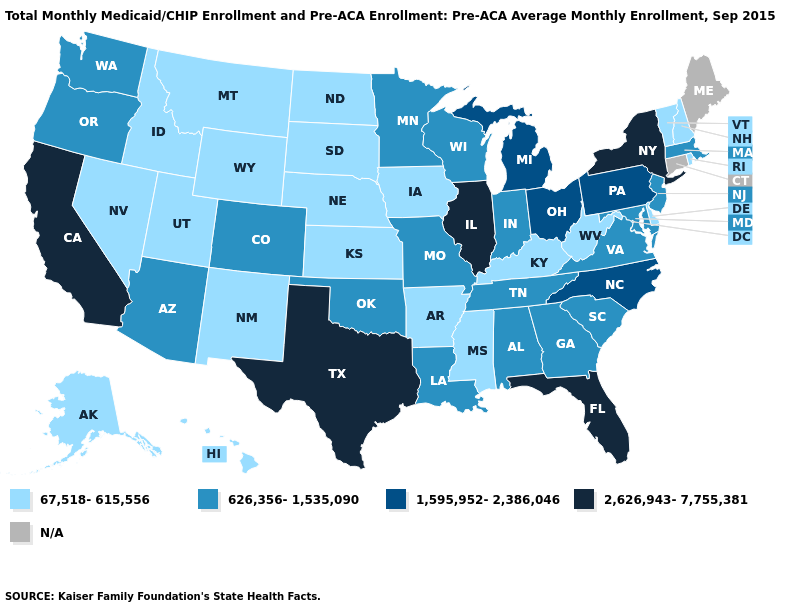Which states have the lowest value in the USA?
Be succinct. Alaska, Arkansas, Delaware, Hawaii, Idaho, Iowa, Kansas, Kentucky, Mississippi, Montana, Nebraska, Nevada, New Hampshire, New Mexico, North Dakota, Rhode Island, South Dakota, Utah, Vermont, West Virginia, Wyoming. What is the lowest value in the Northeast?
Short answer required. 67,518-615,556. Name the states that have a value in the range 2,626,943-7,755,381?
Quick response, please. California, Florida, Illinois, New York, Texas. Does California have the highest value in the USA?
Short answer required. Yes. Among the states that border Arkansas , does Louisiana have the highest value?
Quick response, please. No. Among the states that border Michigan , does Indiana have the lowest value?
Answer briefly. Yes. What is the lowest value in the USA?
Quick response, please. 67,518-615,556. Does Missouri have the lowest value in the USA?
Write a very short answer. No. Does the map have missing data?
Be succinct. Yes. Among the states that border Indiana , which have the lowest value?
Quick response, please. Kentucky. What is the value of Georgia?
Write a very short answer. 626,356-1,535,090. How many symbols are there in the legend?
Short answer required. 5. Is the legend a continuous bar?
Concise answer only. No. Which states have the highest value in the USA?
Write a very short answer. California, Florida, Illinois, New York, Texas. 